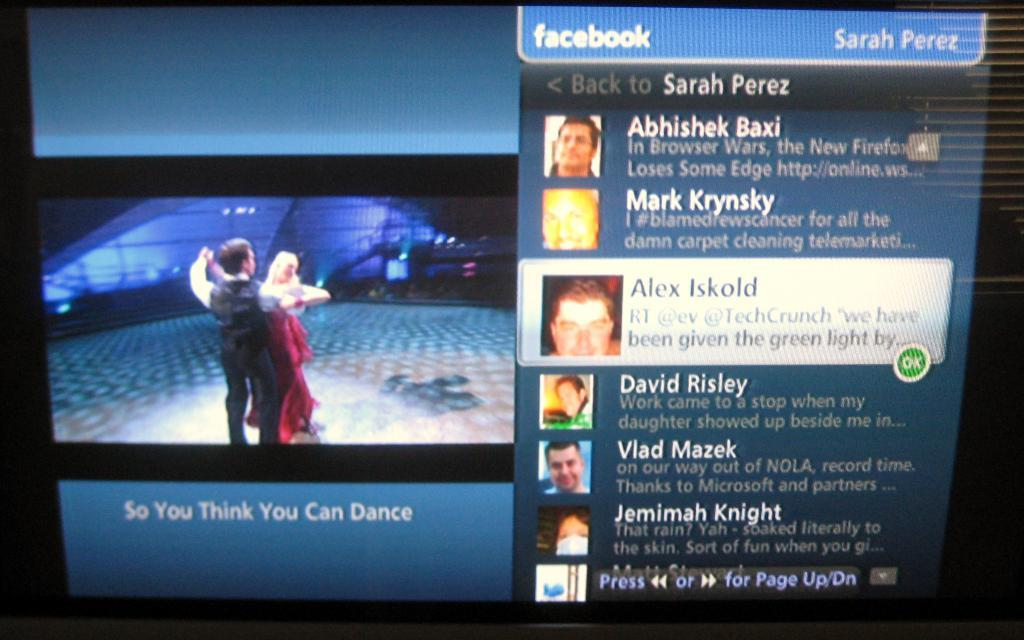<image>
Give a short and clear explanation of the subsequent image. Someone is watching So You Think You Can Dance on Facebook. 